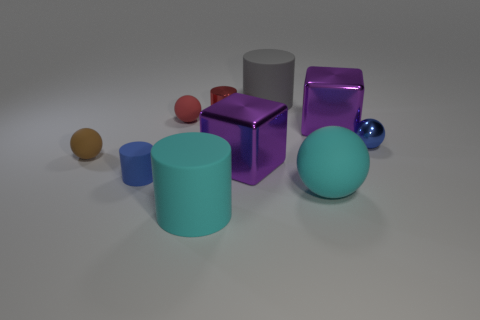What number of cubes are purple metal things or red matte objects?
Provide a succinct answer. 2. What number of things are yellow rubber objects or small balls that are behind the blue metal ball?
Offer a very short reply. 1. Are there any yellow rubber cubes?
Offer a terse response. No. What number of big cubes are the same color as the big ball?
Ensure brevity in your answer.  0. What is the material of the thing that is the same color as the small rubber cylinder?
Make the answer very short. Metal. There is a cyan object behind the big cylinder that is in front of the shiny cylinder; what size is it?
Keep it short and to the point. Large. Are there any tiny green things that have the same material as the small brown sphere?
Your answer should be very brief. No. There is a brown thing that is the same size as the red ball; what material is it?
Give a very brief answer. Rubber. There is a tiny metal sphere that is behind the large cyan cylinder; does it have the same color as the small cylinder that is left of the tiny red matte sphere?
Your answer should be very brief. Yes. There is a thing behind the small red metal object; is there a purple cube that is behind it?
Offer a terse response. No. 